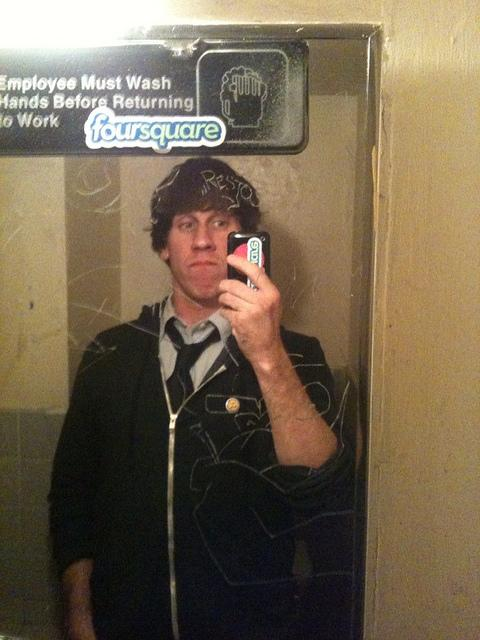Who took the photo of this man? Please explain your reasoning. this man. The man is taking a selfie. 